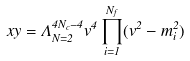Convert formula to latex. <formula><loc_0><loc_0><loc_500><loc_500>x y = \Lambda ^ { 4 N _ { c } - 4 } _ { N = 2 } v ^ { 4 } \prod _ { i = 1 } ^ { N _ { f } } ( v ^ { 2 } - m _ { i } ^ { 2 } )</formula> 